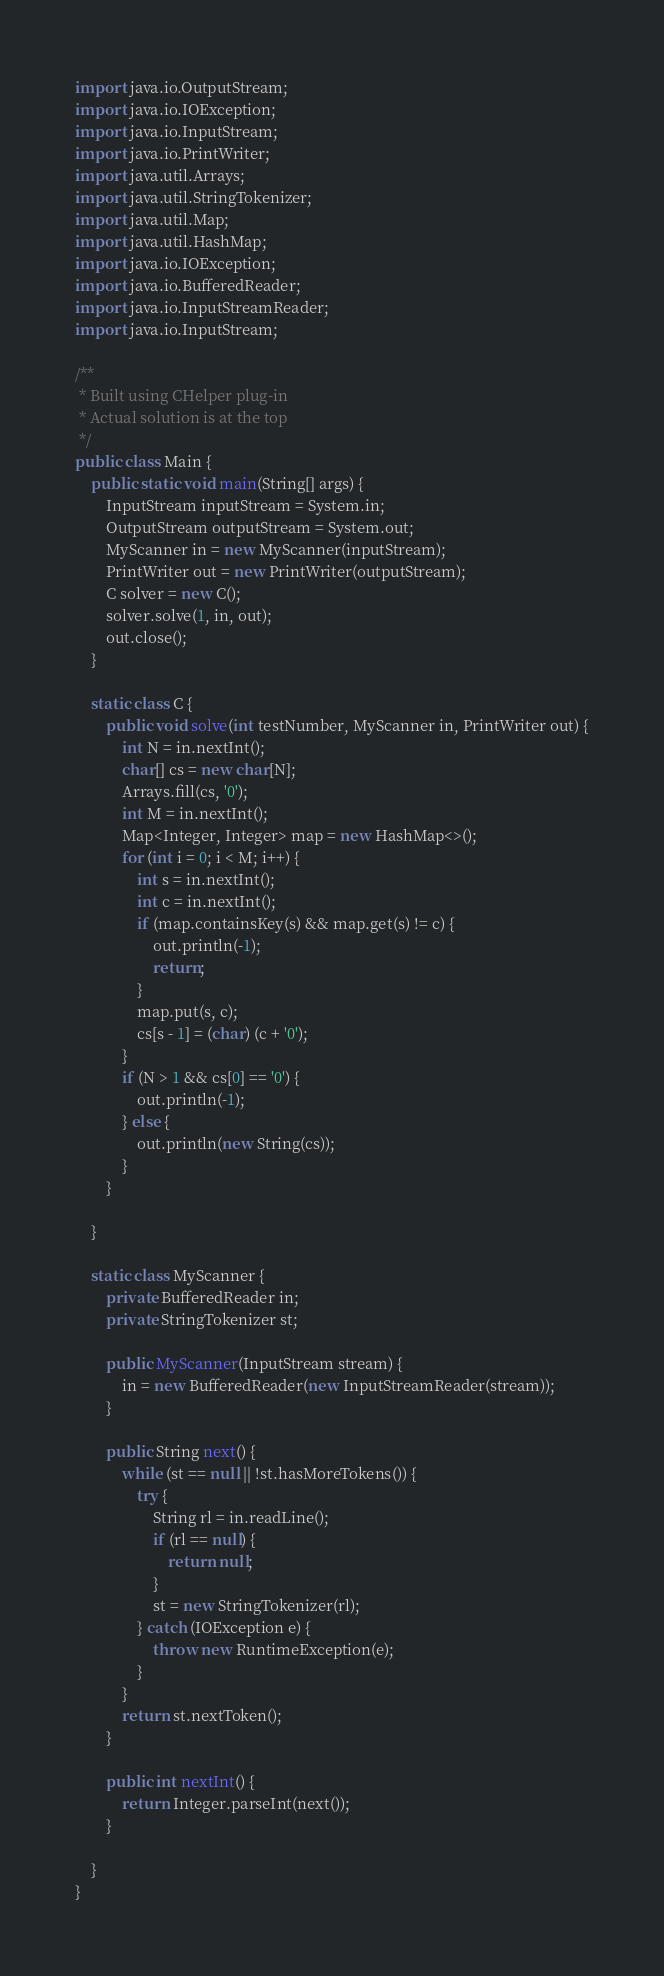Convert code to text. <code><loc_0><loc_0><loc_500><loc_500><_Java_>import java.io.OutputStream;
import java.io.IOException;
import java.io.InputStream;
import java.io.PrintWriter;
import java.util.Arrays;
import java.util.StringTokenizer;
import java.util.Map;
import java.util.HashMap;
import java.io.IOException;
import java.io.BufferedReader;
import java.io.InputStreamReader;
import java.io.InputStream;

/**
 * Built using CHelper plug-in
 * Actual solution is at the top
 */
public class Main {
    public static void main(String[] args) {
        InputStream inputStream = System.in;
        OutputStream outputStream = System.out;
        MyScanner in = new MyScanner(inputStream);
        PrintWriter out = new PrintWriter(outputStream);
        C solver = new C();
        solver.solve(1, in, out);
        out.close();
    }

    static class C {
        public void solve(int testNumber, MyScanner in, PrintWriter out) {
            int N = in.nextInt();
            char[] cs = new char[N];
            Arrays.fill(cs, '0');
            int M = in.nextInt();
            Map<Integer, Integer> map = new HashMap<>();
            for (int i = 0; i < M; i++) {
                int s = in.nextInt();
                int c = in.nextInt();
                if (map.containsKey(s) && map.get(s) != c) {
                    out.println(-1);
                    return;
                }
                map.put(s, c);
                cs[s - 1] = (char) (c + '0');
            }
            if (N > 1 && cs[0] == '0') {
                out.println(-1);
            } else {
                out.println(new String(cs));
            }
        }

    }

    static class MyScanner {
        private BufferedReader in;
        private StringTokenizer st;

        public MyScanner(InputStream stream) {
            in = new BufferedReader(new InputStreamReader(stream));
        }

        public String next() {
            while (st == null || !st.hasMoreTokens()) {
                try {
                    String rl = in.readLine();
                    if (rl == null) {
                        return null;
                    }
                    st = new StringTokenizer(rl);
                } catch (IOException e) {
                    throw new RuntimeException(e);
                }
            }
            return st.nextToken();
        }

        public int nextInt() {
            return Integer.parseInt(next());
        }

    }
}

</code> 